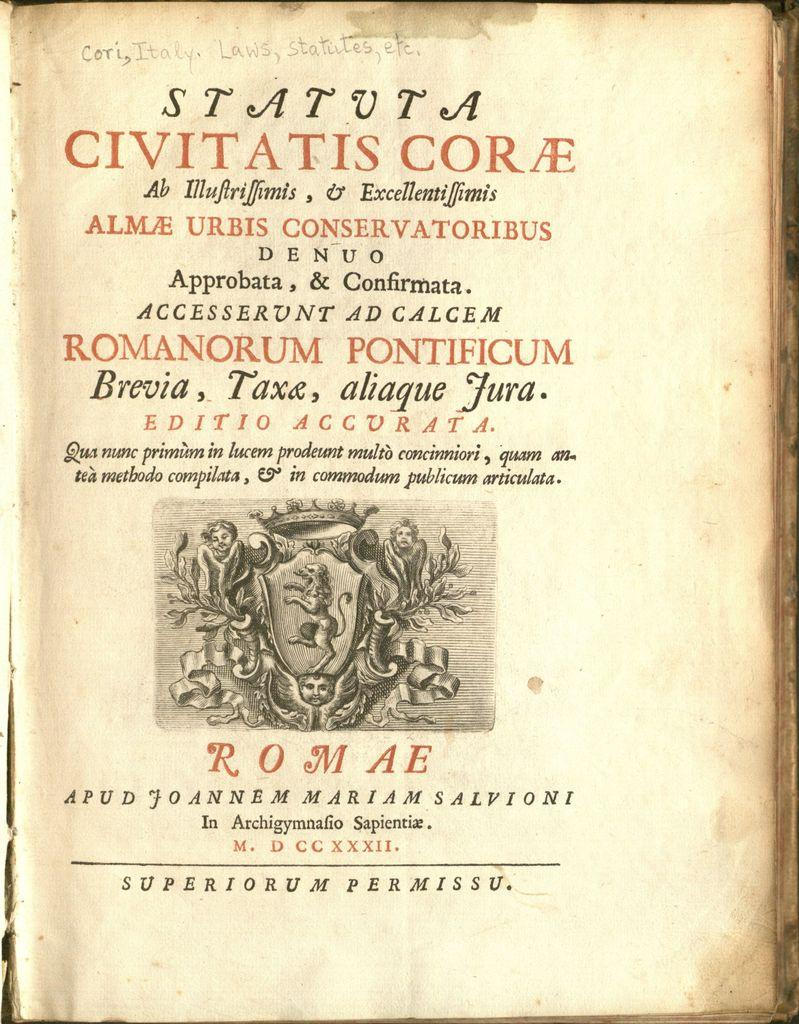What is the main subject of the image? The main subject of the image is a page of a book. What can be seen on the page? There is an image of a photo and text written on the page. What does the maid look like in the image? There is no maid present in the image; it features a page of a book with a photo and text. 